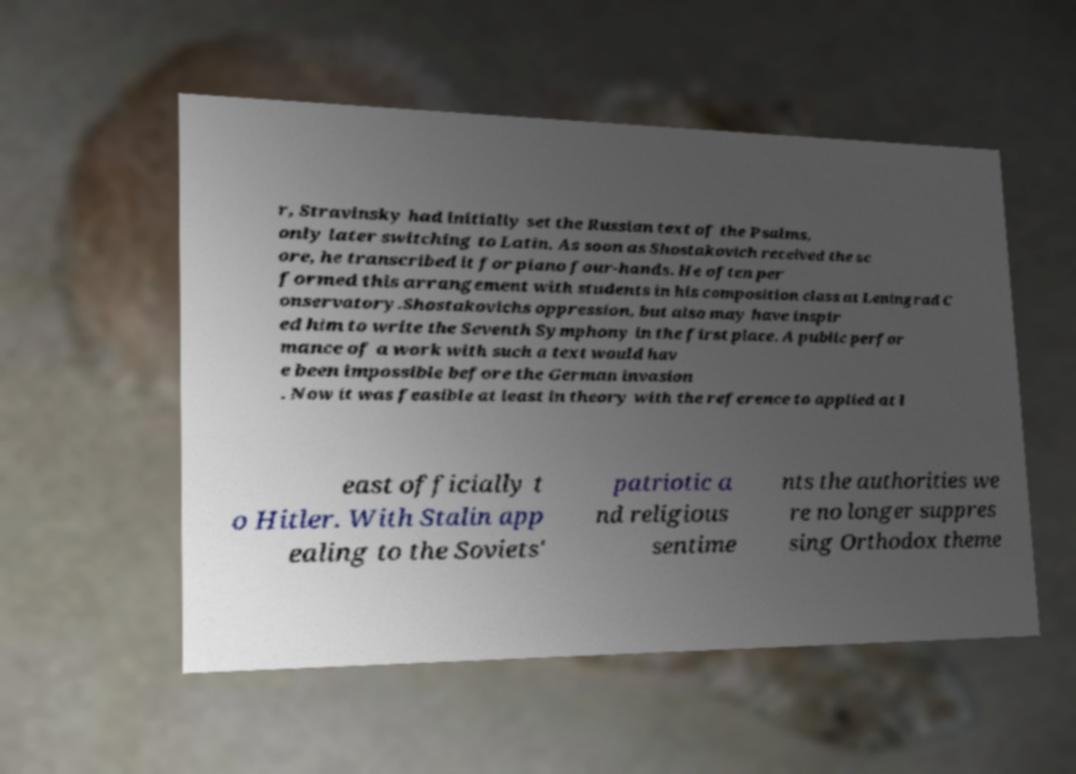Can you accurately transcribe the text from the provided image for me? r, Stravinsky had initially set the Russian text of the Psalms, only later switching to Latin. As soon as Shostakovich received the sc ore, he transcribed it for piano four-hands. He often per formed this arrangement with students in his composition class at Leningrad C onservatory.Shostakovichs oppression, but also may have inspir ed him to write the Seventh Symphony in the first place. A public perfor mance of a work with such a text would hav e been impossible before the German invasion . Now it was feasible at least in theory with the reference to applied at l east officially t o Hitler. With Stalin app ealing to the Soviets' patriotic a nd religious sentime nts the authorities we re no longer suppres sing Orthodox theme 